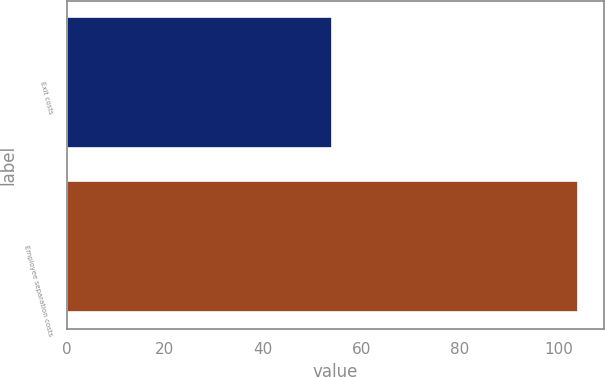<chart> <loc_0><loc_0><loc_500><loc_500><bar_chart><fcel>Exit costs<fcel>Employee separation costs<nl><fcel>54<fcel>104<nl></chart> 